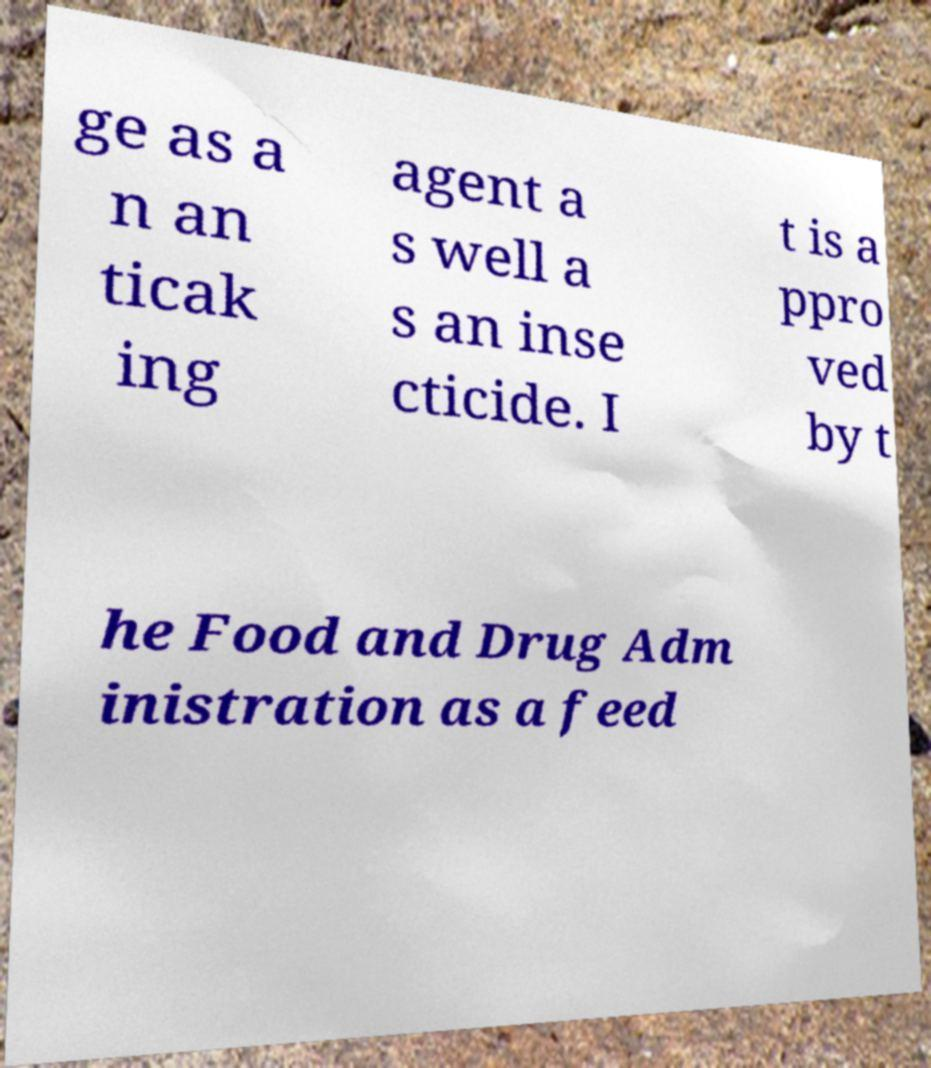Could you extract and type out the text from this image? ge as a n an ticak ing agent a s well a s an inse cticide. I t is a ppro ved by t he Food and Drug Adm inistration as a feed 